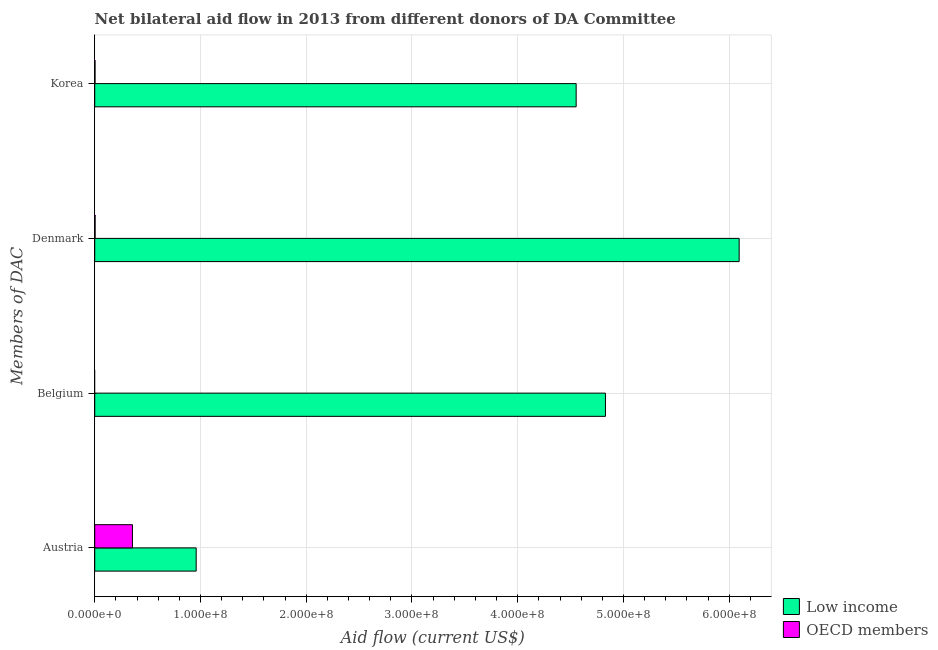Are the number of bars on each tick of the Y-axis equal?
Ensure brevity in your answer.  No. How many bars are there on the 1st tick from the top?
Your response must be concise. 2. What is the label of the 1st group of bars from the top?
Ensure brevity in your answer.  Korea. What is the amount of aid given by korea in OECD members?
Offer a very short reply. 2.80e+05. Across all countries, what is the maximum amount of aid given by denmark?
Provide a succinct answer. 6.09e+08. Across all countries, what is the minimum amount of aid given by austria?
Give a very brief answer. 3.57e+07. In which country was the amount of aid given by belgium maximum?
Your answer should be very brief. Low income. What is the total amount of aid given by korea in the graph?
Your answer should be compact. 4.56e+08. What is the difference between the amount of aid given by denmark in OECD members and that in Low income?
Your response must be concise. -6.09e+08. What is the difference between the amount of aid given by korea in OECD members and the amount of aid given by austria in Low income?
Provide a short and direct response. -9.56e+07. What is the average amount of aid given by austria per country?
Give a very brief answer. 6.58e+07. What is the difference between the amount of aid given by austria and amount of aid given by denmark in OECD members?
Offer a terse response. 3.53e+07. What is the ratio of the amount of aid given by austria in Low income to that in OECD members?
Ensure brevity in your answer.  2.69. Is the amount of aid given by korea in Low income less than that in OECD members?
Ensure brevity in your answer.  No. Is the difference between the amount of aid given by denmark in Low income and OECD members greater than the difference between the amount of aid given by korea in Low income and OECD members?
Your response must be concise. Yes. What is the difference between the highest and the second highest amount of aid given by austria?
Provide a succinct answer. 6.03e+07. What is the difference between the highest and the lowest amount of aid given by korea?
Your answer should be compact. 4.55e+08. Is the sum of the amount of aid given by austria in Low income and OECD members greater than the maximum amount of aid given by denmark across all countries?
Your answer should be compact. No. Is it the case that in every country, the sum of the amount of aid given by austria and amount of aid given by belgium is greater than the amount of aid given by denmark?
Offer a very short reply. No. What is the difference between two consecutive major ticks on the X-axis?
Your response must be concise. 1.00e+08. Are the values on the major ticks of X-axis written in scientific E-notation?
Your response must be concise. Yes. Does the graph contain grids?
Provide a short and direct response. Yes. Where does the legend appear in the graph?
Offer a terse response. Bottom right. How many legend labels are there?
Provide a short and direct response. 2. How are the legend labels stacked?
Keep it short and to the point. Vertical. What is the title of the graph?
Provide a succinct answer. Net bilateral aid flow in 2013 from different donors of DA Committee. What is the label or title of the Y-axis?
Offer a very short reply. Members of DAC. What is the Aid flow (current US$) in Low income in Austria?
Your response must be concise. 9.59e+07. What is the Aid flow (current US$) in OECD members in Austria?
Your response must be concise. 3.57e+07. What is the Aid flow (current US$) of Low income in Belgium?
Your answer should be compact. 4.83e+08. What is the Aid flow (current US$) in OECD members in Belgium?
Give a very brief answer. 0. What is the Aid flow (current US$) in Low income in Denmark?
Give a very brief answer. 6.09e+08. What is the Aid flow (current US$) of OECD members in Denmark?
Give a very brief answer. 3.60e+05. What is the Aid flow (current US$) in Low income in Korea?
Provide a succinct answer. 4.55e+08. Across all Members of DAC, what is the maximum Aid flow (current US$) of Low income?
Provide a succinct answer. 6.09e+08. Across all Members of DAC, what is the maximum Aid flow (current US$) of OECD members?
Keep it short and to the point. 3.57e+07. Across all Members of DAC, what is the minimum Aid flow (current US$) of Low income?
Provide a succinct answer. 9.59e+07. What is the total Aid flow (current US$) in Low income in the graph?
Offer a terse response. 1.64e+09. What is the total Aid flow (current US$) of OECD members in the graph?
Offer a terse response. 3.63e+07. What is the difference between the Aid flow (current US$) in Low income in Austria and that in Belgium?
Provide a succinct answer. -3.87e+08. What is the difference between the Aid flow (current US$) of Low income in Austria and that in Denmark?
Make the answer very short. -5.13e+08. What is the difference between the Aid flow (current US$) of OECD members in Austria and that in Denmark?
Provide a short and direct response. 3.53e+07. What is the difference between the Aid flow (current US$) in Low income in Austria and that in Korea?
Your answer should be very brief. -3.59e+08. What is the difference between the Aid flow (current US$) in OECD members in Austria and that in Korea?
Ensure brevity in your answer.  3.54e+07. What is the difference between the Aid flow (current US$) of Low income in Belgium and that in Denmark?
Make the answer very short. -1.26e+08. What is the difference between the Aid flow (current US$) of Low income in Belgium and that in Korea?
Your answer should be very brief. 2.77e+07. What is the difference between the Aid flow (current US$) in Low income in Denmark and that in Korea?
Ensure brevity in your answer.  1.54e+08. What is the difference between the Aid flow (current US$) in Low income in Austria and the Aid flow (current US$) in OECD members in Denmark?
Offer a very short reply. 9.56e+07. What is the difference between the Aid flow (current US$) in Low income in Austria and the Aid flow (current US$) in OECD members in Korea?
Your answer should be compact. 9.56e+07. What is the difference between the Aid flow (current US$) in Low income in Belgium and the Aid flow (current US$) in OECD members in Denmark?
Your answer should be very brief. 4.83e+08. What is the difference between the Aid flow (current US$) in Low income in Belgium and the Aid flow (current US$) in OECD members in Korea?
Your response must be concise. 4.83e+08. What is the difference between the Aid flow (current US$) in Low income in Denmark and the Aid flow (current US$) in OECD members in Korea?
Provide a short and direct response. 6.09e+08. What is the average Aid flow (current US$) in Low income per Members of DAC?
Ensure brevity in your answer.  4.11e+08. What is the average Aid flow (current US$) of OECD members per Members of DAC?
Give a very brief answer. 9.08e+06. What is the difference between the Aid flow (current US$) in Low income and Aid flow (current US$) in OECD members in Austria?
Provide a short and direct response. 6.03e+07. What is the difference between the Aid flow (current US$) of Low income and Aid flow (current US$) of OECD members in Denmark?
Offer a terse response. 6.09e+08. What is the difference between the Aid flow (current US$) of Low income and Aid flow (current US$) of OECD members in Korea?
Make the answer very short. 4.55e+08. What is the ratio of the Aid flow (current US$) of Low income in Austria to that in Belgium?
Your answer should be very brief. 0.2. What is the ratio of the Aid flow (current US$) in Low income in Austria to that in Denmark?
Your answer should be very brief. 0.16. What is the ratio of the Aid flow (current US$) of OECD members in Austria to that in Denmark?
Offer a terse response. 99.06. What is the ratio of the Aid flow (current US$) of Low income in Austria to that in Korea?
Your answer should be very brief. 0.21. What is the ratio of the Aid flow (current US$) of OECD members in Austria to that in Korea?
Keep it short and to the point. 127.36. What is the ratio of the Aid flow (current US$) of Low income in Belgium to that in Denmark?
Provide a succinct answer. 0.79. What is the ratio of the Aid flow (current US$) of Low income in Belgium to that in Korea?
Give a very brief answer. 1.06. What is the ratio of the Aid flow (current US$) of Low income in Denmark to that in Korea?
Offer a terse response. 1.34. What is the difference between the highest and the second highest Aid flow (current US$) in Low income?
Your answer should be compact. 1.26e+08. What is the difference between the highest and the second highest Aid flow (current US$) of OECD members?
Keep it short and to the point. 3.53e+07. What is the difference between the highest and the lowest Aid flow (current US$) in Low income?
Offer a terse response. 5.13e+08. What is the difference between the highest and the lowest Aid flow (current US$) of OECD members?
Keep it short and to the point. 3.57e+07. 